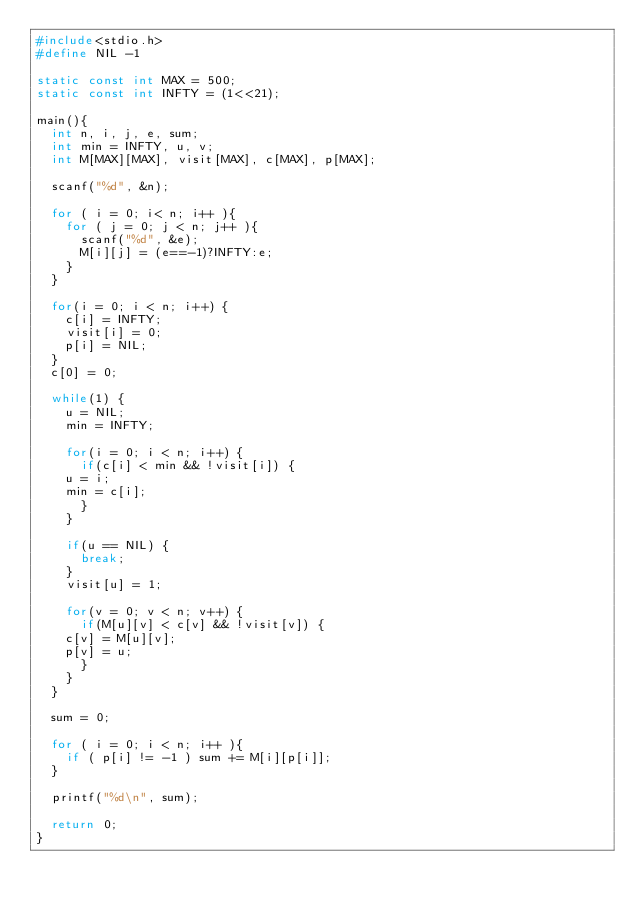<code> <loc_0><loc_0><loc_500><loc_500><_C_>#include<stdio.h>
#define NIL -1

static const int MAX = 500;
static const int INFTY = (1<<21);

main(){
  int n, i, j, e, sum;
  int min = INFTY, u, v;
  int M[MAX][MAX], visit[MAX], c[MAX], p[MAX];

  scanf("%d", &n);

  for ( i = 0; i< n; i++ ){
    for ( j = 0; j < n; j++ ){
      scanf("%d", &e);
      M[i][j] = (e==-1)?INFTY:e;
    }
  }

  for(i = 0; i < n; i++) {
    c[i] = INFTY;
    visit[i] = 0;
    p[i] = NIL;
  }
  c[0] = 0;

  while(1) {
    u = NIL;
    min = INFTY;

    for(i = 0; i < n; i++) {
      if(c[i] < min && !visit[i]) {
	u = i;
	min = c[i];
      }
    }

    if(u == NIL) {
      break;
    }
    visit[u] = 1;

    for(v = 0; v < n; v++) {
      if(M[u][v] < c[v] && !visit[v]) {
	c[v] = M[u][v];
	p[v] = u;
      }
    }
  }

  sum = 0;

  for ( i = 0; i < n; i++ ){
    if ( p[i] != -1 ) sum += M[i][p[i]];
  }

  printf("%d\n", sum);

  return 0;
}</code> 